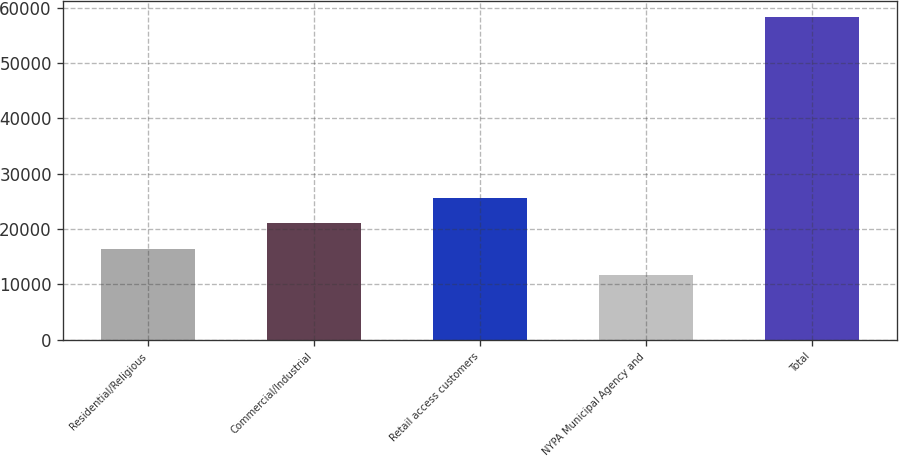Convert chart to OTSL. <chart><loc_0><loc_0><loc_500><loc_500><bar_chart><fcel>Residential/Religious<fcel>Commercial/Industrial<fcel>Retail access customers<fcel>NYPA Municipal Agency and<fcel>Total<nl><fcel>16365.9<fcel>21027.8<fcel>25689.7<fcel>11704<fcel>58323<nl></chart> 